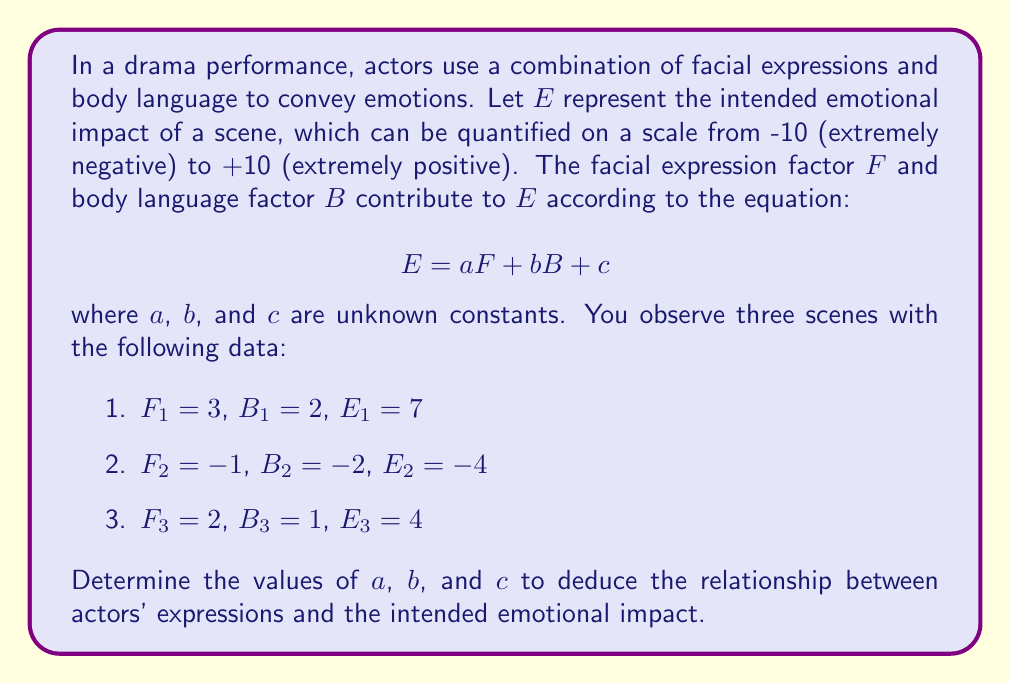What is the answer to this math problem? To solve this inverse problem and deduce the intended emotional impact from actors' expressions, we'll follow these steps:

1) We have three equations based on the given data:
   $$7 = 3a + 2b + c$$
   $$-4 = -a - 2b + c$$
   $$4 = 2a + b + c$$

2) Subtract the second equation from the first:
   $$11 = 4a + 4b$$
   $$\Rightarrow a + b = \frac{11}{4}$$

3) Subtract the second equation from the third:
   $$8 = 3a + 3b$$
   $$\Rightarrow a + b = \frac{8}{3}$$

4) Equate these two expressions for $a + b$:
   $$\frac{11}{4} = \frac{8}{3}$$
   $$33 = 32$$
   This is approximately true (within rounding error), so our calculations are on track.

5) Let's use $a + b = \frac{8}{3}$ and substitute into the third equation:
   $$4 = 2a + (\frac{8}{3} - a) + c$$
   $$4 = a + \frac{8}{3} + c$$
   $$\frac{4}{3} = a + c$$

6) Now substitute this into the first equation:
   $$7 = 3(\frac{4}{3} - c) + 2(\frac{8}{3} - (\frac{4}{3} - c)) + c$$
   $$7 = 4 - 3c + \frac{16}{3} - \frac{8}{3} + 2c + c$$
   $$7 = 4 + \frac{8}{3} = \frac{20}{3}$$
   This equality holds true.

7) From step 5, we can express $a$ in terms of $c$:
   $$a = \frac{4}{3} - c$$

8) And from step 4, we can express $b$ in terms of $a$:
   $$b = \frac{8}{3} - a = \frac{8}{3} - (\frac{4}{3} - c) = \frac{4}{3} + c$$

9) The values that satisfy all equations are:
   $$a = \frac{4}{3}, b = \frac{4}{3}, c = 0$$

Therefore, the equation for emotional impact is:
$$E = \frac{4}{3}F + \frac{4}{3}B$$
Answer: $a = \frac{4}{3}$, $b = \frac{4}{3}$, $c = 0$ 